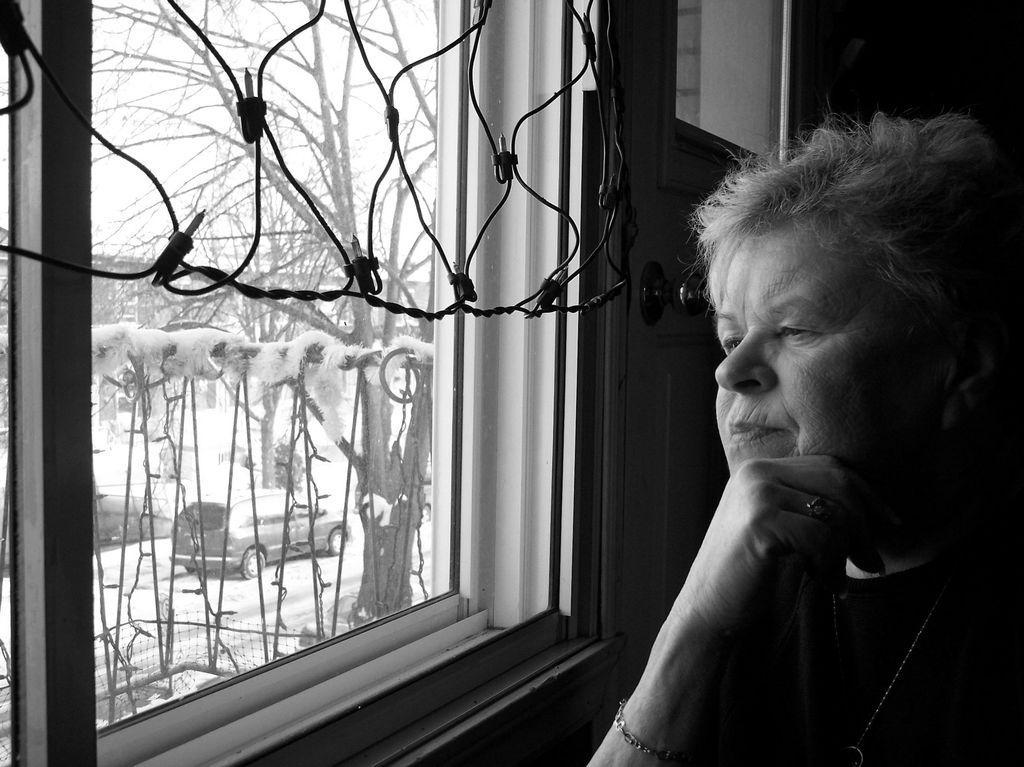Can you describe this image briefly? In the picture I can see a woman. In the background I can see trees, a window, a vehicle, the sky and some other things. This picture is black and white in color. 